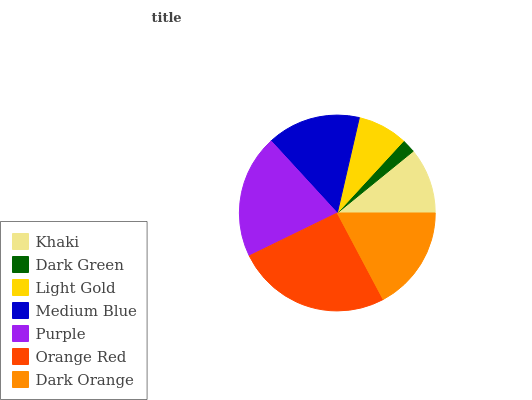Is Dark Green the minimum?
Answer yes or no. Yes. Is Orange Red the maximum?
Answer yes or no. Yes. Is Light Gold the minimum?
Answer yes or no. No. Is Light Gold the maximum?
Answer yes or no. No. Is Light Gold greater than Dark Green?
Answer yes or no. Yes. Is Dark Green less than Light Gold?
Answer yes or no. Yes. Is Dark Green greater than Light Gold?
Answer yes or no. No. Is Light Gold less than Dark Green?
Answer yes or no. No. Is Medium Blue the high median?
Answer yes or no. Yes. Is Medium Blue the low median?
Answer yes or no. Yes. Is Light Gold the high median?
Answer yes or no. No. Is Purple the low median?
Answer yes or no. No. 